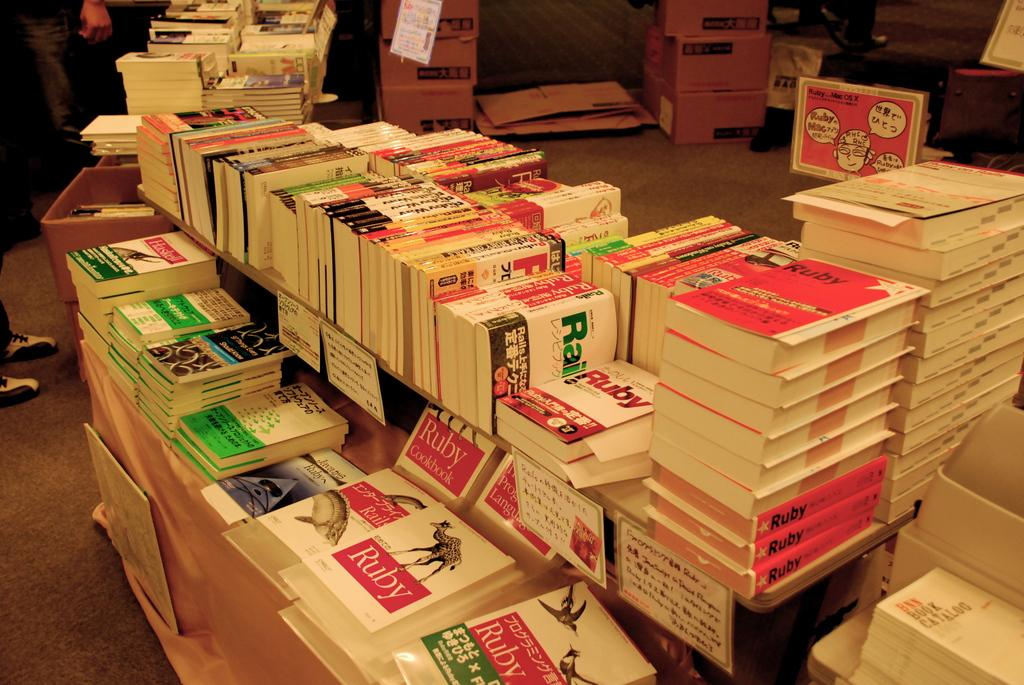Provide a one-sentence caption for the provided image. A variety of books are stacked on a table, some with the word Ruby on the cover. 